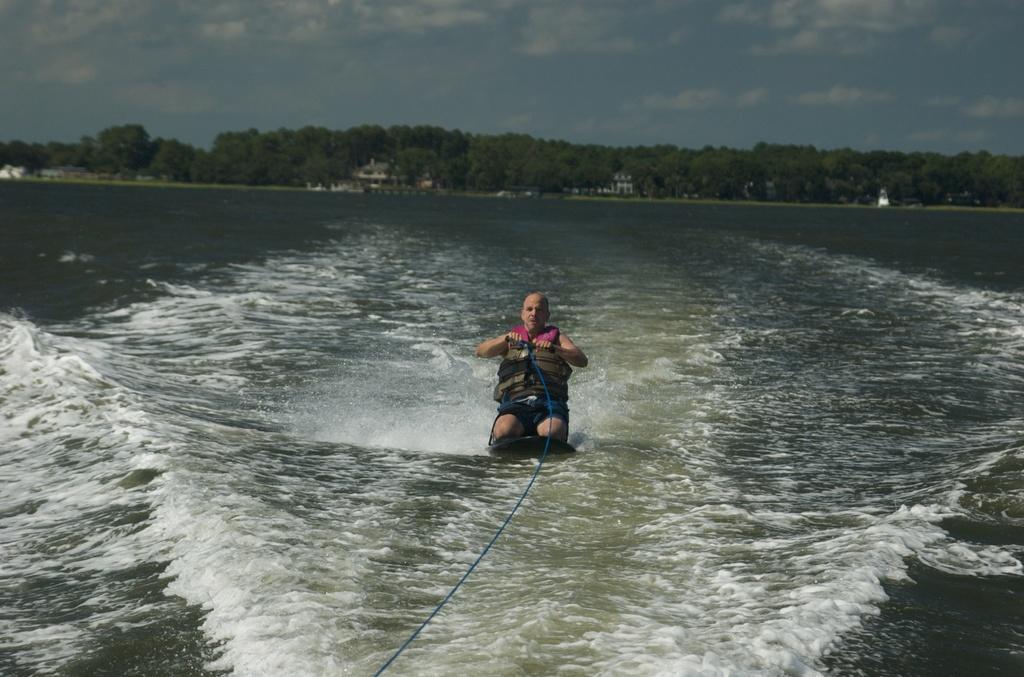Describe this image in one or two sentences. This picture is taken in a river. In the center, there is a person sitting on the board and holding a rope. In the background, there are trees and a sky with clouds. 